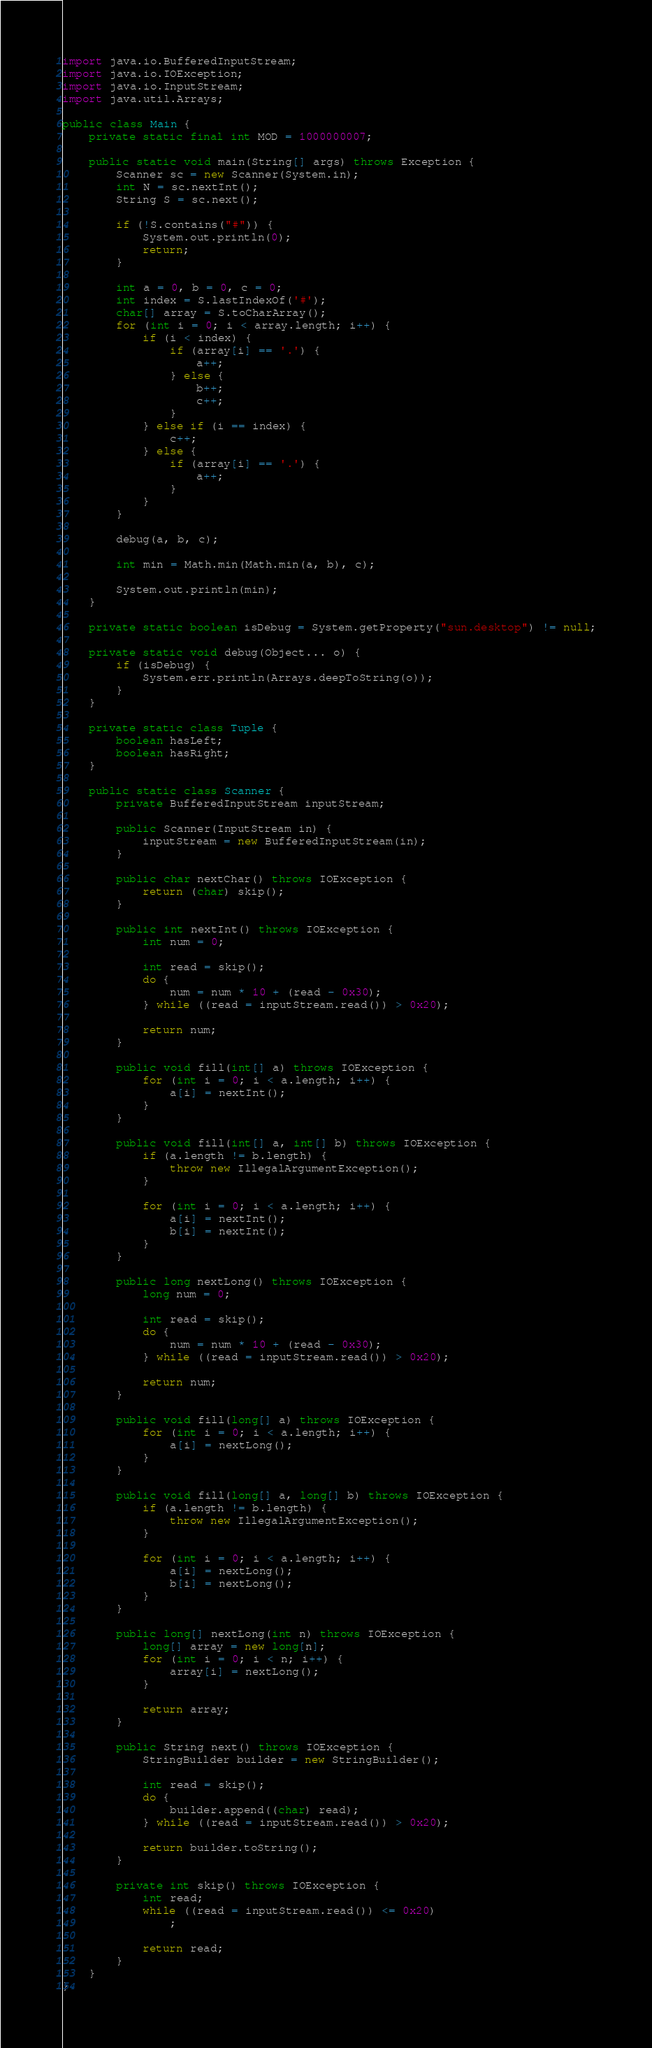Convert code to text. <code><loc_0><loc_0><loc_500><loc_500><_Java_>import java.io.BufferedInputStream;
import java.io.IOException;
import java.io.InputStream;
import java.util.Arrays;

public class Main {
	private static final int MOD = 1000000007;

	public static void main(String[] args) throws Exception {
		Scanner sc = new Scanner(System.in);
		int N = sc.nextInt();
		String S = sc.next();

		if (!S.contains("#")) {
			System.out.println(0);
			return;
		}

		int a = 0, b = 0, c = 0;
		int index = S.lastIndexOf('#');
		char[] array = S.toCharArray();
		for (int i = 0; i < array.length; i++) {
			if (i < index) {
				if (array[i] == '.') {
					a++;
				} else {
					b++;
					c++;
				}
			} else if (i == index) {
				c++;
			} else {
				if (array[i] == '.') {
					a++;
				}
			}
		}

		debug(a, b, c);

		int min = Math.min(Math.min(a, b), c);

		System.out.println(min);
	}

	private static boolean isDebug = System.getProperty("sun.desktop") != null;

	private static void debug(Object... o) {
		if (isDebug) {
			System.err.println(Arrays.deepToString(o));
		}
	}

	private static class Tuple {
		boolean hasLeft;
		boolean hasRight;
	}

	public static class Scanner {
		private BufferedInputStream inputStream;

		public Scanner(InputStream in) {
			inputStream = new BufferedInputStream(in);
		}

		public char nextChar() throws IOException {
			return (char) skip();
		}

		public int nextInt() throws IOException {
			int num = 0;

			int read = skip();
			do {
				num = num * 10 + (read - 0x30);
			} while ((read = inputStream.read()) > 0x20);

			return num;
		}

		public void fill(int[] a) throws IOException {
			for (int i = 0; i < a.length; i++) {
				a[i] = nextInt();
			}
		}

		public void fill(int[] a, int[] b) throws IOException {
			if (a.length != b.length) {
				throw new IllegalArgumentException();
			}

			for (int i = 0; i < a.length; i++) {
				a[i] = nextInt();
				b[i] = nextInt();
			}
		}

		public long nextLong() throws IOException {
			long num = 0;

			int read = skip();
			do {
				num = num * 10 + (read - 0x30);
			} while ((read = inputStream.read()) > 0x20);

			return num;
		}

		public void fill(long[] a) throws IOException {
			for (int i = 0; i < a.length; i++) {
				a[i] = nextLong();
			}
		}

		public void fill(long[] a, long[] b) throws IOException {
			if (a.length != b.length) {
				throw new IllegalArgumentException();
			}

			for (int i = 0; i < a.length; i++) {
				a[i] = nextLong();
				b[i] = nextLong();
			}
		}

		public long[] nextLong(int n) throws IOException {
			long[] array = new long[n];
			for (int i = 0; i < n; i++) {
				array[i] = nextLong();
			}

			return array;
		}

		public String next() throws IOException {
			StringBuilder builder = new StringBuilder();

			int read = skip();
			do {
				builder.append((char) read);
			} while ((read = inputStream.read()) > 0x20);

			return builder.toString();
		}

		private int skip() throws IOException {
			int read;
			while ((read = inputStream.read()) <= 0x20)
				;

			return read;
		}
	}
}</code> 